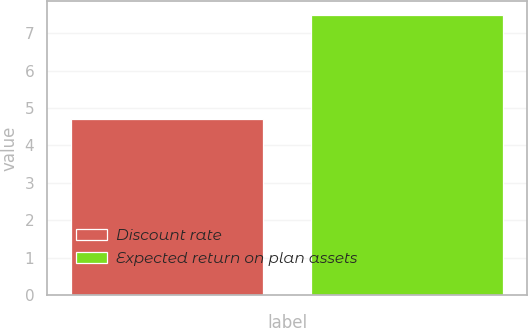Convert chart to OTSL. <chart><loc_0><loc_0><loc_500><loc_500><bar_chart><fcel>Discount rate<fcel>Expected return on plan assets<nl><fcel>4.7<fcel>7.5<nl></chart> 